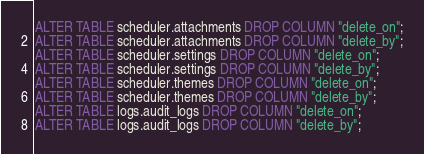<code> <loc_0><loc_0><loc_500><loc_500><_SQL_>ALTER TABLE scheduler.attachments DROP COLUMN "delete_on";
ALTER TABLE scheduler.attachments DROP COLUMN "delete_by";
ALTER TABLE scheduler.settings DROP COLUMN "delete_on";
ALTER TABLE scheduler.settings DROP COLUMN "delete_by";
ALTER TABLE scheduler.themes DROP COLUMN "delete_on";
ALTER TABLE scheduler.themes DROP COLUMN "delete_by";
ALTER TABLE logs.audit_logs DROP COLUMN "delete_on";
ALTER TABLE logs.audit_logs DROP COLUMN "delete_by";</code> 